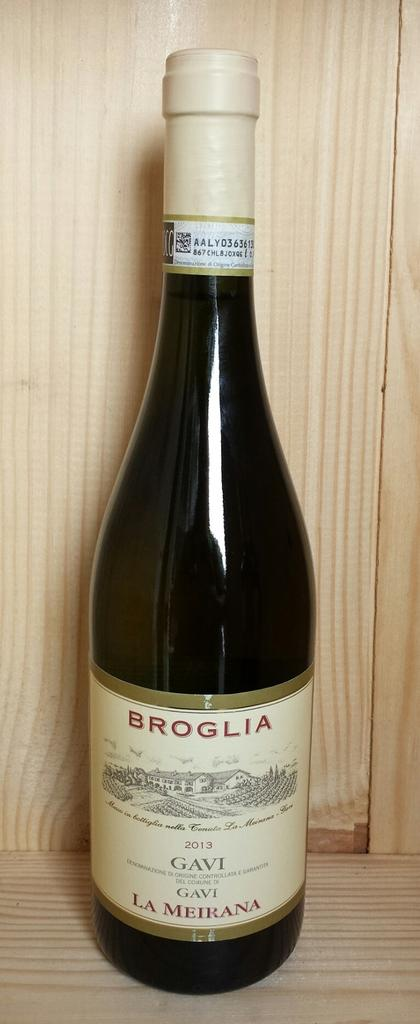Provide a one-sentence caption for the provided image. a bottle of Broglia Gavi wine in a wood case. 